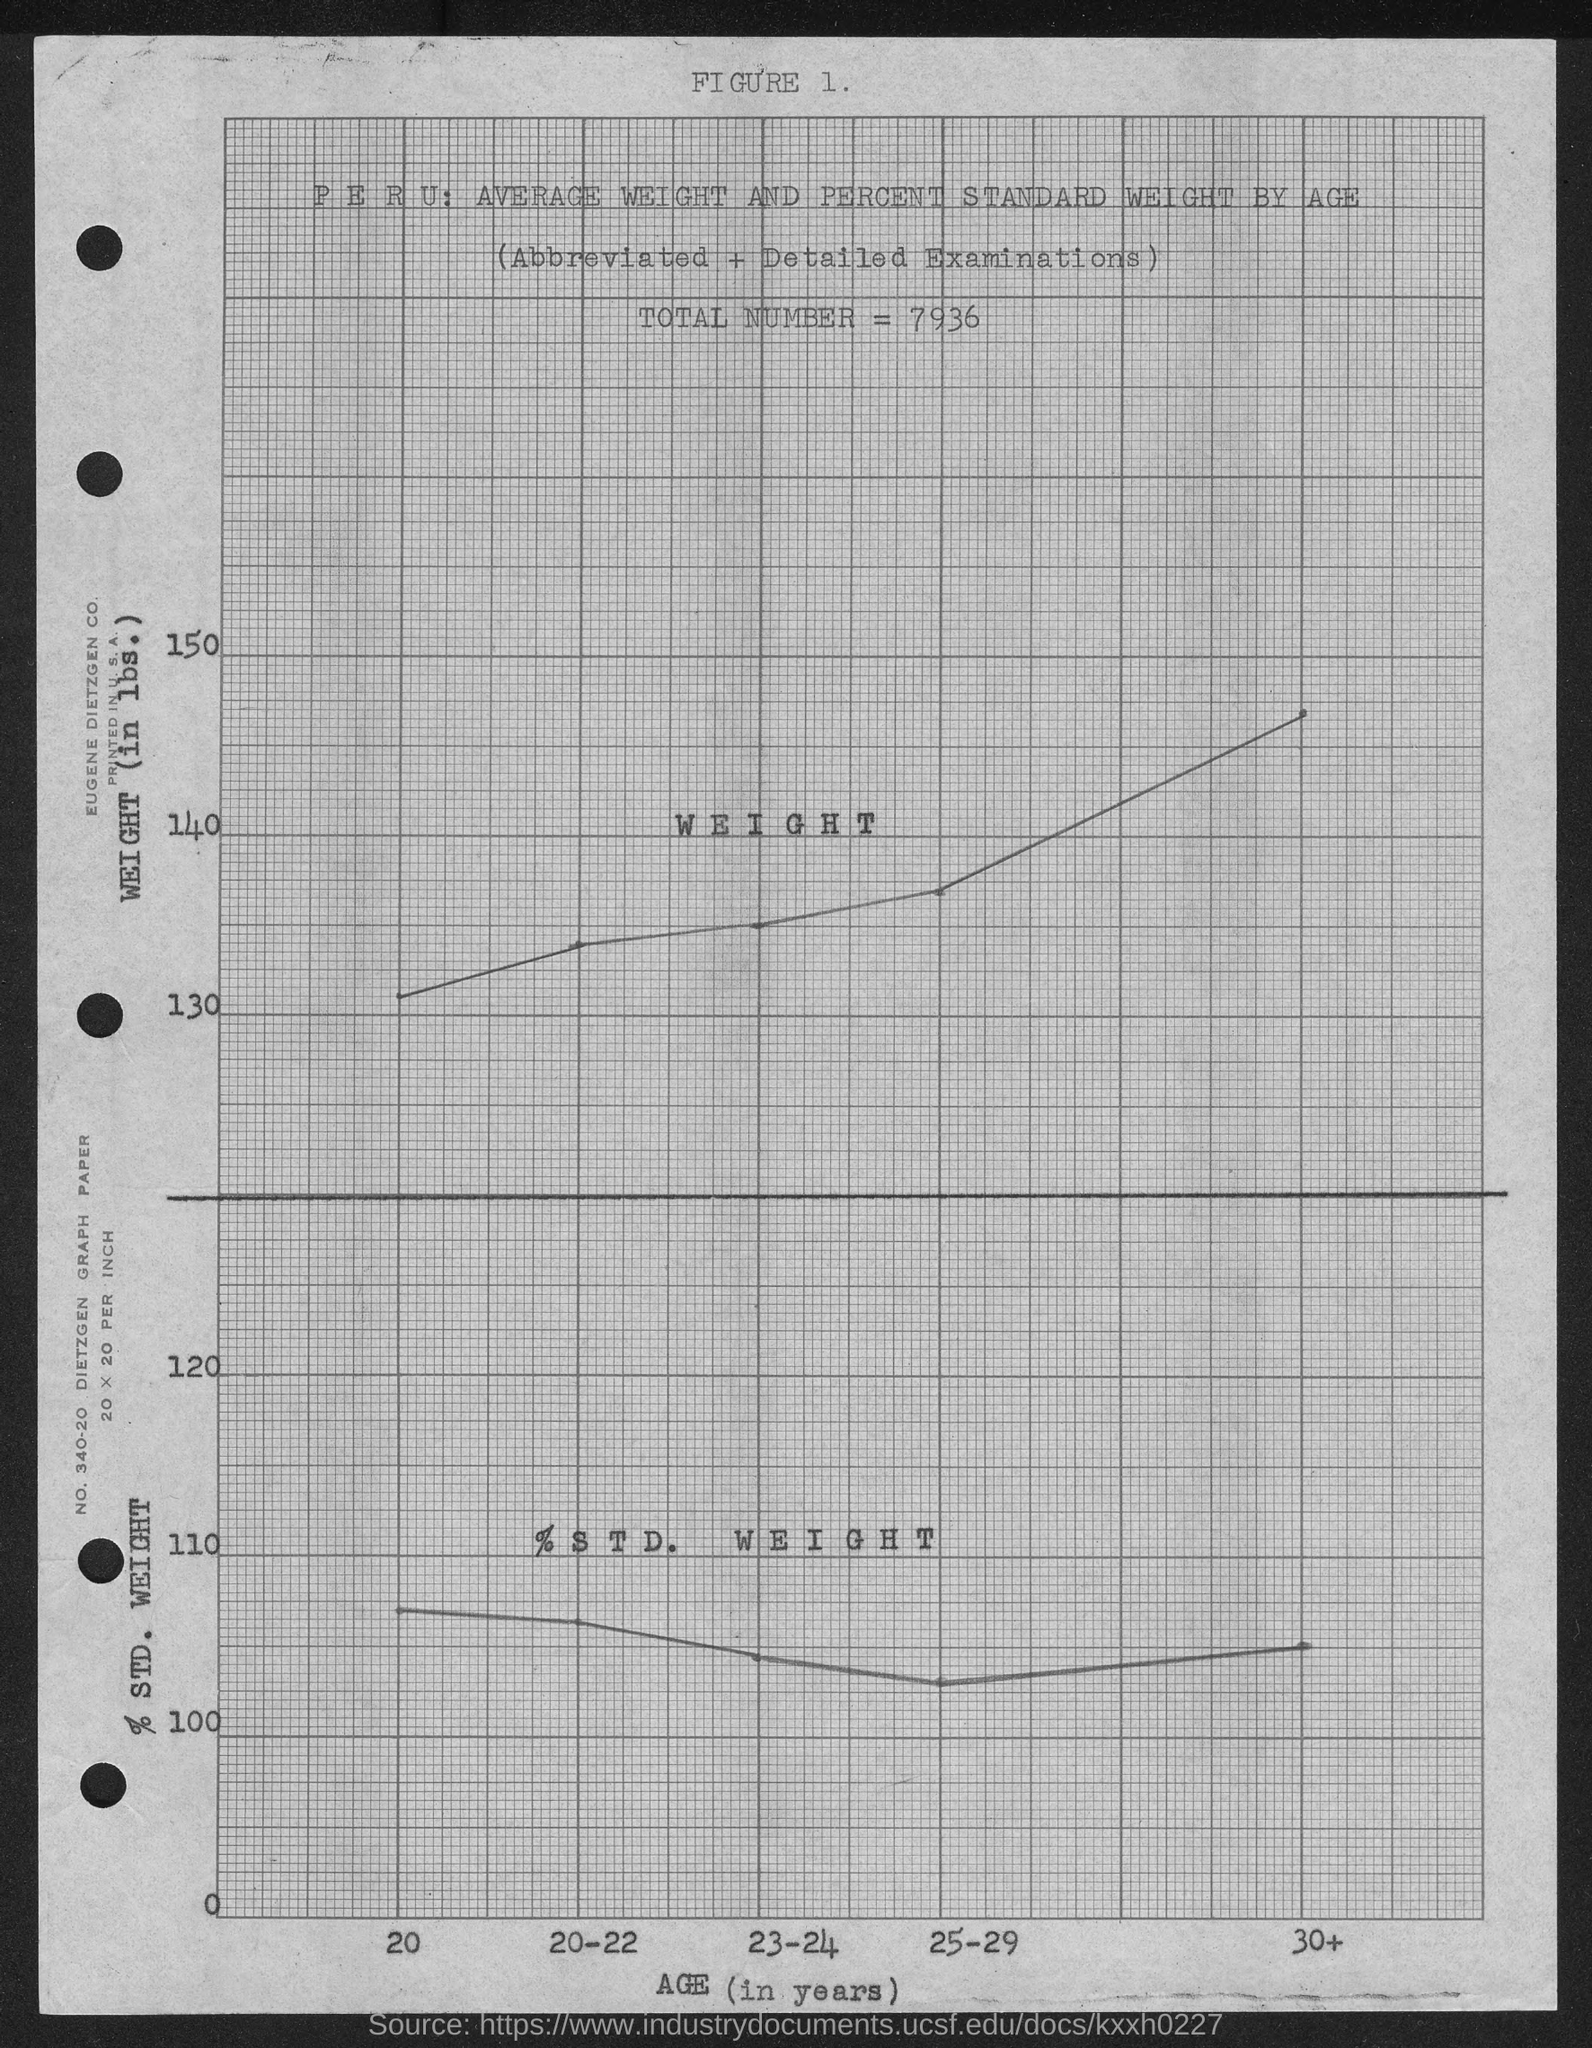List a handful of essential elements in this visual. The given graph shows a total number of 7936. 